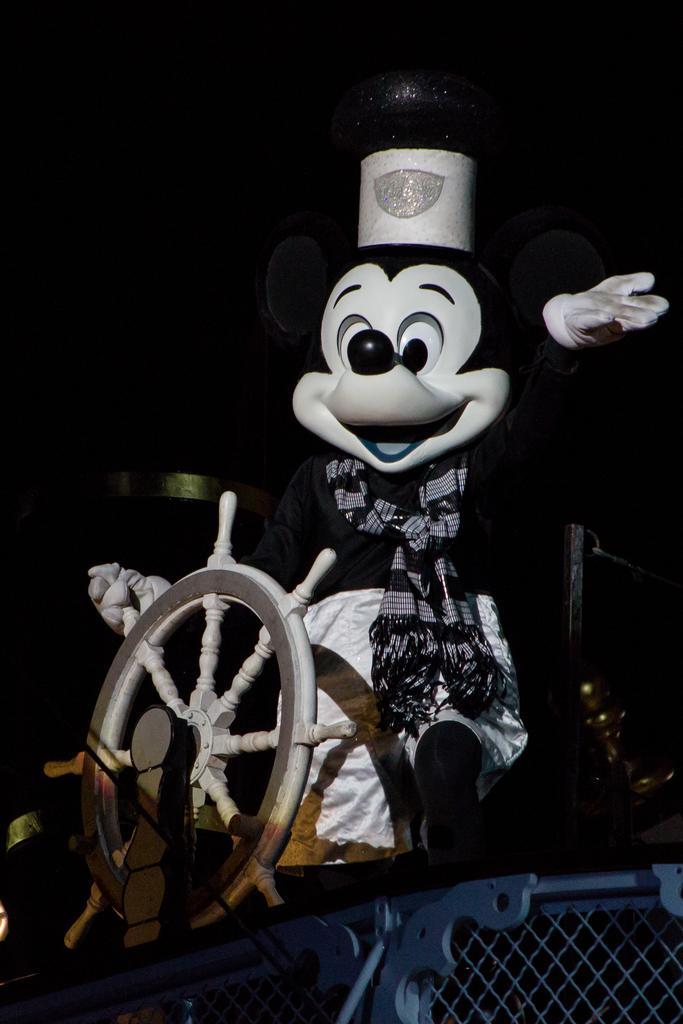Describe this image in one or two sentences. In this image we can see a cartoon and there is a wheel. At the bottom there is a fence. 